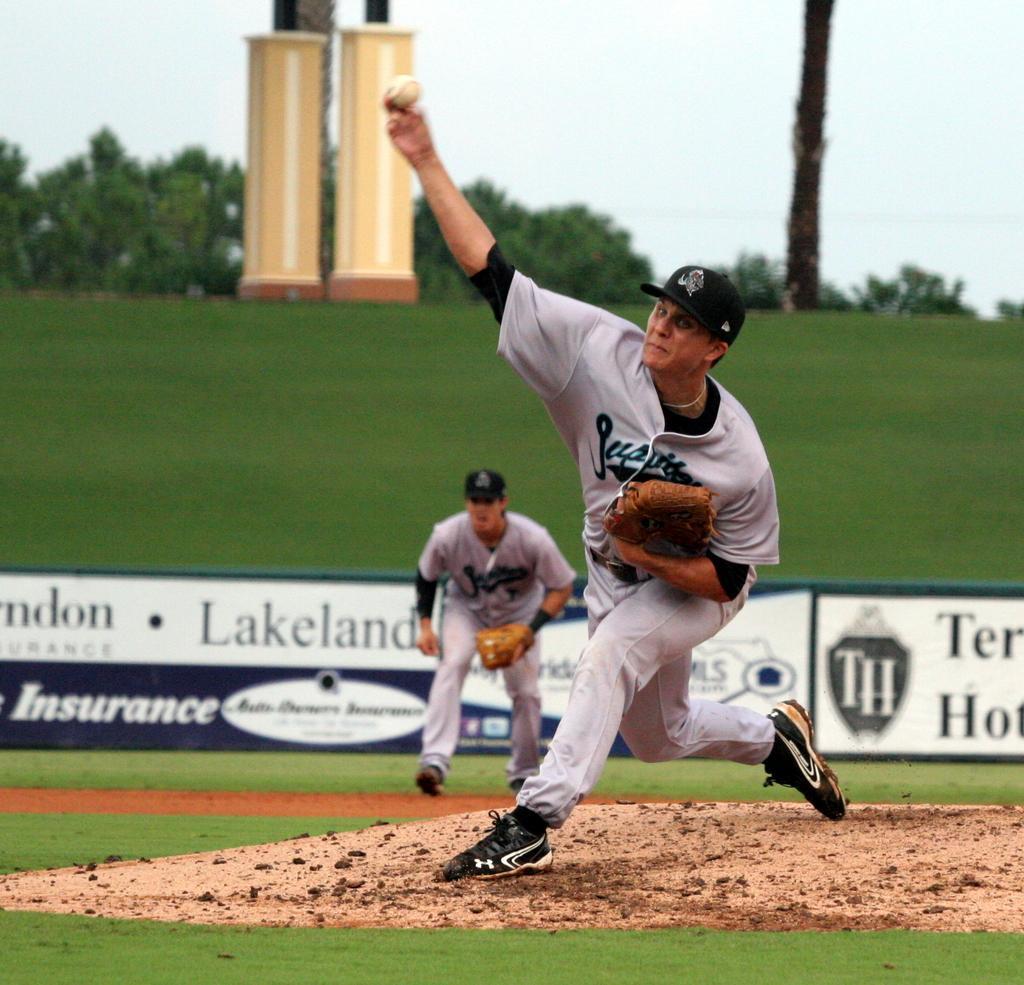In one or two sentences, can you explain what this image depicts? In this Image I can see a person holding something and a ball. He is wearing white dress and black shoes. Back I can see a person,banner,trees and pillars. The sky is in white and blue color. 